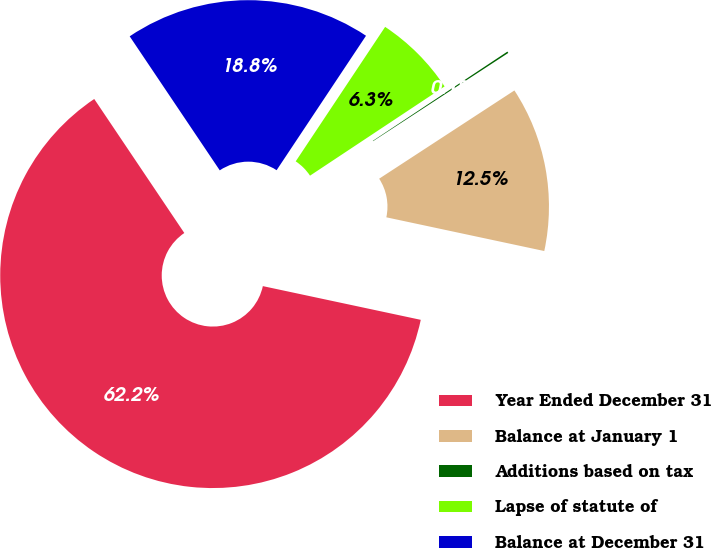Convert chart to OTSL. <chart><loc_0><loc_0><loc_500><loc_500><pie_chart><fcel>Year Ended December 31<fcel>Balance at January 1<fcel>Additions based on tax<fcel>Lapse of statute of<fcel>Balance at December 31<nl><fcel>62.24%<fcel>12.55%<fcel>0.12%<fcel>6.34%<fcel>18.76%<nl></chart> 